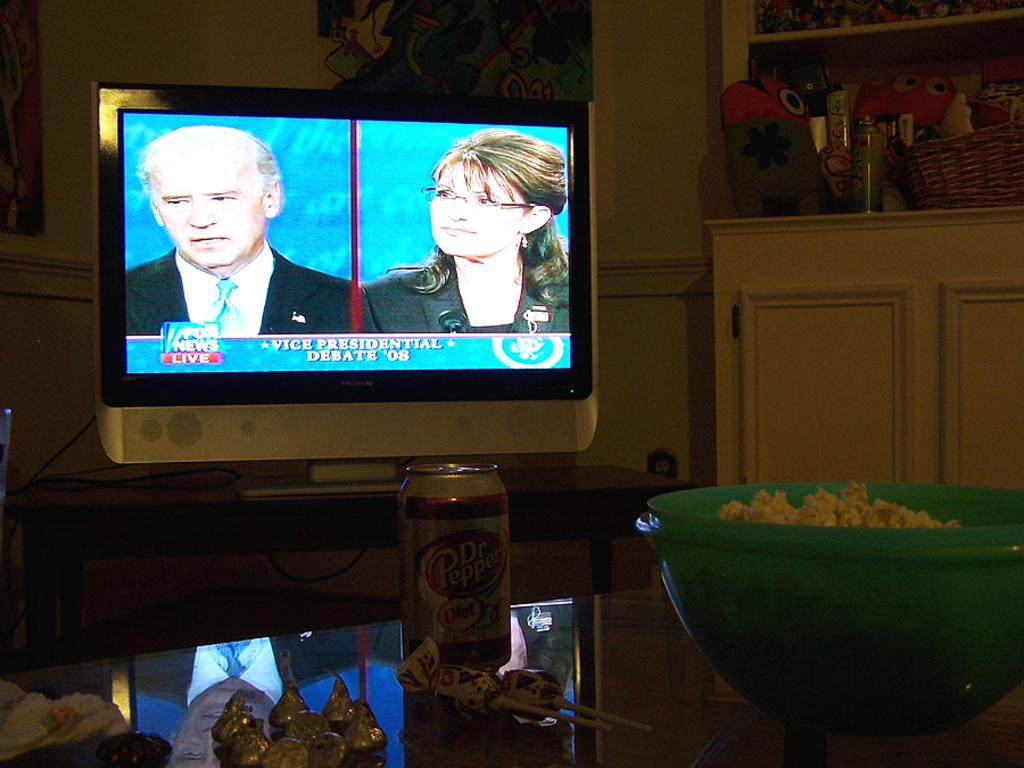<image>
Summarize the visual content of the image. A TV screen displays a debate on Fox News Live. 